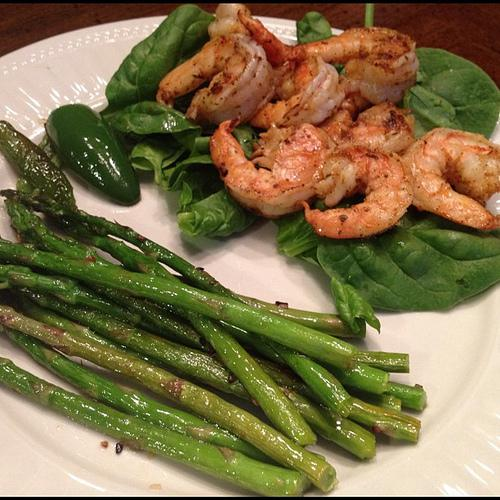Question: who grows asparagus?
Choices:
A. Factory worker.
B. Teacher.
C. Construction worker.
D. Farmer.
Answer with the letter. Answer: D Question: what color are the shrimps?
Choices:
A. Pink.
B. Red.
C. White.
D. Orange.
Answer with the letter. Answer: A Question: where are the shrimps?
Choices:
A. In cocktail sauce.
B. On pasta.
C. In soup.
D. On spinach.
Answer with the letter. Answer: D Question: what kind of spears are seen?
Choices:
A. Carrots.
B. Asparagus.
C. Celery.
D. Hunting.
Answer with the letter. Answer: B Question: how many shrimps are visible?
Choices:
A. Eight.
B. Four.
C. Five.
D. Six.
Answer with the letter. Answer: A 